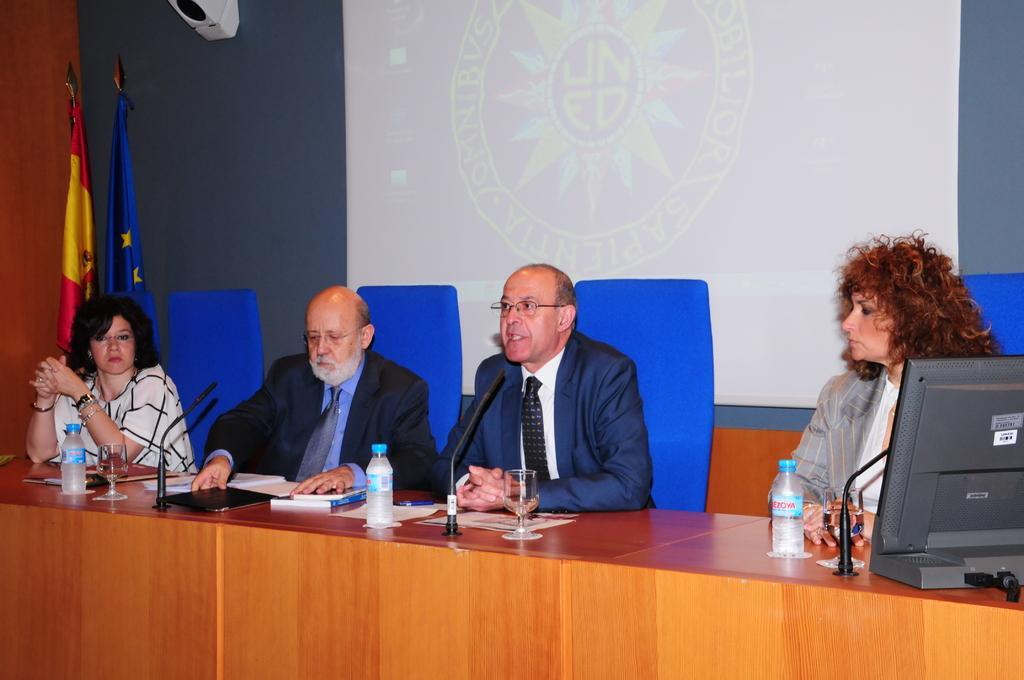Can you describe this image briefly? There are four members sitting in front of a table having a microphone in front of them. Two of them are men and the remaining two are women. Women are seated at the very edge on either side. Everyone is having a bottle on the table in front of them. Men are wearing a coat, shirt and a tie. Behind these four people there is a projector screen on the wall. Behind the woman who is sitting at the left edge there are two flags. One is blue colour and the other one is red and yellow. The woman who is sitting in the right edge having a monitor in front of her and she is looking at the remaining three persons. 